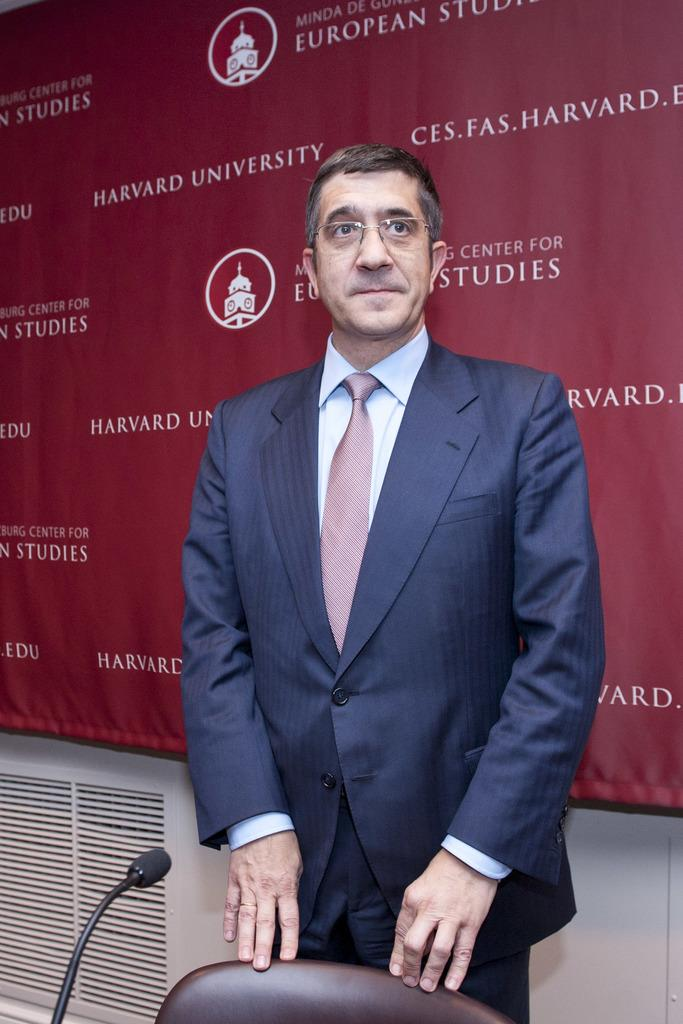What is the man in the image doing? The man is standing in the image. Where is the man standing in relation to other objects in the image? The man is standing at a chair. What object is visible in the image that is typically used for amplifying sound? There is a microphone in the image. What can be seen in the background of the image? There is a banner and a wall in the background of the image. What object is located at the bottom on the left side of the image? There is an object at the bottom on the left side of the image. What type of baseball can be seen in the image? There is no baseball present in the image. How many balls are visible in the image? There are no balls visible in the image. 